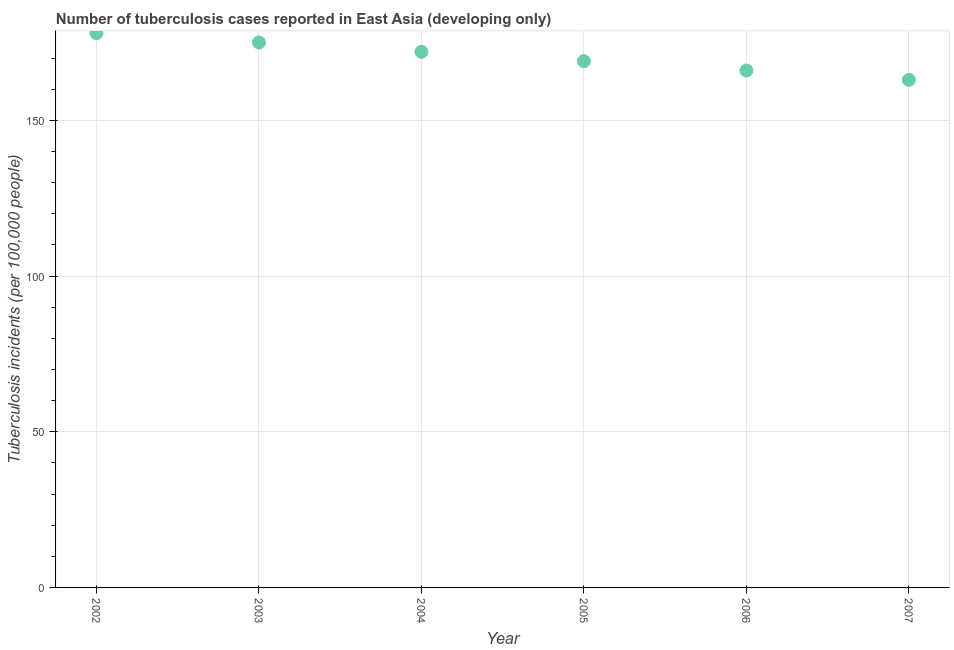What is the number of tuberculosis incidents in 2005?
Your answer should be very brief. 169. Across all years, what is the maximum number of tuberculosis incidents?
Keep it short and to the point. 178. Across all years, what is the minimum number of tuberculosis incidents?
Your answer should be very brief. 163. In which year was the number of tuberculosis incidents maximum?
Make the answer very short. 2002. In which year was the number of tuberculosis incidents minimum?
Make the answer very short. 2007. What is the sum of the number of tuberculosis incidents?
Provide a short and direct response. 1023. What is the difference between the number of tuberculosis incidents in 2002 and 2007?
Offer a very short reply. 15. What is the average number of tuberculosis incidents per year?
Give a very brief answer. 170.5. What is the median number of tuberculosis incidents?
Offer a terse response. 170.5. Do a majority of the years between 2005 and 2007 (inclusive) have number of tuberculosis incidents greater than 60 ?
Ensure brevity in your answer.  Yes. What is the ratio of the number of tuberculosis incidents in 2002 to that in 2003?
Make the answer very short. 1.02. Is the number of tuberculosis incidents in 2002 less than that in 2004?
Provide a short and direct response. No. Is the difference between the number of tuberculosis incidents in 2003 and 2007 greater than the difference between any two years?
Provide a short and direct response. No. Is the sum of the number of tuberculosis incidents in 2003 and 2004 greater than the maximum number of tuberculosis incidents across all years?
Offer a terse response. Yes. What is the difference between the highest and the lowest number of tuberculosis incidents?
Ensure brevity in your answer.  15. What is the difference between two consecutive major ticks on the Y-axis?
Give a very brief answer. 50. Are the values on the major ticks of Y-axis written in scientific E-notation?
Your answer should be compact. No. What is the title of the graph?
Offer a very short reply. Number of tuberculosis cases reported in East Asia (developing only). What is the label or title of the Y-axis?
Keep it short and to the point. Tuberculosis incidents (per 100,0 people). What is the Tuberculosis incidents (per 100,000 people) in 2002?
Ensure brevity in your answer.  178. What is the Tuberculosis incidents (per 100,000 people) in 2003?
Your answer should be compact. 175. What is the Tuberculosis incidents (per 100,000 people) in 2004?
Your answer should be very brief. 172. What is the Tuberculosis incidents (per 100,000 people) in 2005?
Ensure brevity in your answer.  169. What is the Tuberculosis incidents (per 100,000 people) in 2006?
Provide a succinct answer. 166. What is the Tuberculosis incidents (per 100,000 people) in 2007?
Your answer should be compact. 163. What is the difference between the Tuberculosis incidents (per 100,000 people) in 2002 and 2003?
Your answer should be compact. 3. What is the difference between the Tuberculosis incidents (per 100,000 people) in 2002 and 2004?
Provide a succinct answer. 6. What is the difference between the Tuberculosis incidents (per 100,000 people) in 2002 and 2005?
Offer a terse response. 9. What is the difference between the Tuberculosis incidents (per 100,000 people) in 2002 and 2006?
Ensure brevity in your answer.  12. What is the difference between the Tuberculosis incidents (per 100,000 people) in 2002 and 2007?
Offer a very short reply. 15. What is the difference between the Tuberculosis incidents (per 100,000 people) in 2004 and 2005?
Your response must be concise. 3. What is the difference between the Tuberculosis incidents (per 100,000 people) in 2006 and 2007?
Your answer should be very brief. 3. What is the ratio of the Tuberculosis incidents (per 100,000 people) in 2002 to that in 2003?
Ensure brevity in your answer.  1.02. What is the ratio of the Tuberculosis incidents (per 100,000 people) in 2002 to that in 2004?
Offer a terse response. 1.03. What is the ratio of the Tuberculosis incidents (per 100,000 people) in 2002 to that in 2005?
Ensure brevity in your answer.  1.05. What is the ratio of the Tuberculosis incidents (per 100,000 people) in 2002 to that in 2006?
Provide a short and direct response. 1.07. What is the ratio of the Tuberculosis incidents (per 100,000 people) in 2002 to that in 2007?
Ensure brevity in your answer.  1.09. What is the ratio of the Tuberculosis incidents (per 100,000 people) in 2003 to that in 2004?
Your answer should be very brief. 1.02. What is the ratio of the Tuberculosis incidents (per 100,000 people) in 2003 to that in 2005?
Offer a terse response. 1.04. What is the ratio of the Tuberculosis incidents (per 100,000 people) in 2003 to that in 2006?
Your response must be concise. 1.05. What is the ratio of the Tuberculosis incidents (per 100,000 people) in 2003 to that in 2007?
Offer a terse response. 1.07. What is the ratio of the Tuberculosis incidents (per 100,000 people) in 2004 to that in 2006?
Provide a succinct answer. 1.04. What is the ratio of the Tuberculosis incidents (per 100,000 people) in 2004 to that in 2007?
Your response must be concise. 1.05. What is the ratio of the Tuberculosis incidents (per 100,000 people) in 2006 to that in 2007?
Provide a succinct answer. 1.02. 